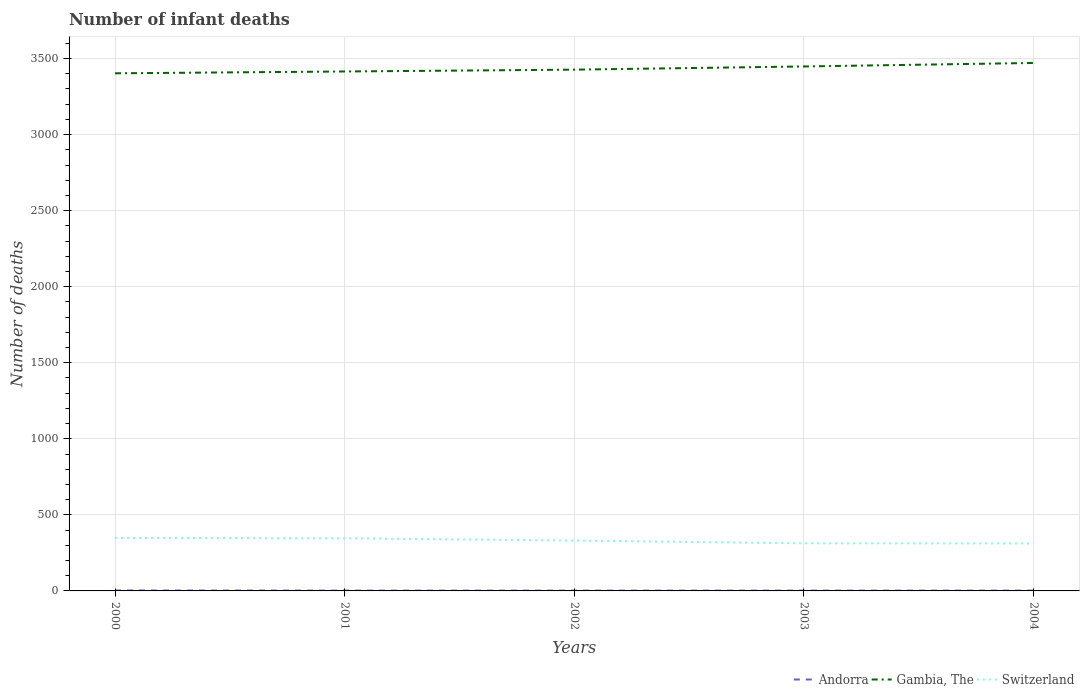Is the number of lines equal to the number of legend labels?
Keep it short and to the point. Yes. What is the total number of infant deaths in Switzerland in the graph?
Your response must be concise. 33. What is the title of the graph?
Your answer should be compact. Number of infant deaths. What is the label or title of the Y-axis?
Offer a terse response. Number of deaths. What is the Number of deaths of Andorra in 2000?
Offer a terse response. 3. What is the Number of deaths in Gambia, The in 2000?
Provide a short and direct response. 3403. What is the Number of deaths of Switzerland in 2000?
Give a very brief answer. 348. What is the Number of deaths in Gambia, The in 2001?
Provide a succinct answer. 3415. What is the Number of deaths in Switzerland in 2001?
Make the answer very short. 346. What is the Number of deaths of Gambia, The in 2002?
Ensure brevity in your answer.  3427. What is the Number of deaths of Switzerland in 2002?
Your answer should be compact. 331. What is the Number of deaths in Gambia, The in 2003?
Your answer should be very brief. 3448. What is the Number of deaths in Switzerland in 2003?
Offer a very short reply. 313. What is the Number of deaths in Andorra in 2004?
Provide a short and direct response. 2. What is the Number of deaths in Gambia, The in 2004?
Offer a very short reply. 3471. What is the Number of deaths of Switzerland in 2004?
Make the answer very short. 312. Across all years, what is the maximum Number of deaths in Gambia, The?
Offer a terse response. 3471. Across all years, what is the maximum Number of deaths in Switzerland?
Your answer should be compact. 348. Across all years, what is the minimum Number of deaths of Gambia, The?
Give a very brief answer. 3403. Across all years, what is the minimum Number of deaths in Switzerland?
Provide a short and direct response. 312. What is the total Number of deaths in Andorra in the graph?
Make the answer very short. 11. What is the total Number of deaths of Gambia, The in the graph?
Provide a short and direct response. 1.72e+04. What is the total Number of deaths of Switzerland in the graph?
Ensure brevity in your answer.  1650. What is the difference between the Number of deaths in Gambia, The in 2000 and that in 2001?
Your answer should be compact. -12. What is the difference between the Number of deaths in Switzerland in 2000 and that in 2001?
Your response must be concise. 2. What is the difference between the Number of deaths of Switzerland in 2000 and that in 2002?
Keep it short and to the point. 17. What is the difference between the Number of deaths in Gambia, The in 2000 and that in 2003?
Your answer should be very brief. -45. What is the difference between the Number of deaths of Andorra in 2000 and that in 2004?
Keep it short and to the point. 1. What is the difference between the Number of deaths in Gambia, The in 2000 and that in 2004?
Ensure brevity in your answer.  -68. What is the difference between the Number of deaths in Andorra in 2001 and that in 2003?
Offer a very short reply. 0. What is the difference between the Number of deaths of Gambia, The in 2001 and that in 2003?
Your response must be concise. -33. What is the difference between the Number of deaths of Switzerland in 2001 and that in 2003?
Provide a short and direct response. 33. What is the difference between the Number of deaths in Andorra in 2001 and that in 2004?
Your response must be concise. 0. What is the difference between the Number of deaths in Gambia, The in 2001 and that in 2004?
Ensure brevity in your answer.  -56. What is the difference between the Number of deaths in Switzerland in 2001 and that in 2004?
Offer a terse response. 34. What is the difference between the Number of deaths of Andorra in 2002 and that in 2003?
Your answer should be very brief. 0. What is the difference between the Number of deaths of Switzerland in 2002 and that in 2003?
Your answer should be compact. 18. What is the difference between the Number of deaths of Andorra in 2002 and that in 2004?
Offer a terse response. 0. What is the difference between the Number of deaths in Gambia, The in 2002 and that in 2004?
Ensure brevity in your answer.  -44. What is the difference between the Number of deaths in Switzerland in 2003 and that in 2004?
Offer a very short reply. 1. What is the difference between the Number of deaths in Andorra in 2000 and the Number of deaths in Gambia, The in 2001?
Provide a succinct answer. -3412. What is the difference between the Number of deaths of Andorra in 2000 and the Number of deaths of Switzerland in 2001?
Your answer should be very brief. -343. What is the difference between the Number of deaths of Gambia, The in 2000 and the Number of deaths of Switzerland in 2001?
Offer a terse response. 3057. What is the difference between the Number of deaths in Andorra in 2000 and the Number of deaths in Gambia, The in 2002?
Your answer should be compact. -3424. What is the difference between the Number of deaths of Andorra in 2000 and the Number of deaths of Switzerland in 2002?
Provide a short and direct response. -328. What is the difference between the Number of deaths in Gambia, The in 2000 and the Number of deaths in Switzerland in 2002?
Give a very brief answer. 3072. What is the difference between the Number of deaths of Andorra in 2000 and the Number of deaths of Gambia, The in 2003?
Keep it short and to the point. -3445. What is the difference between the Number of deaths in Andorra in 2000 and the Number of deaths in Switzerland in 2003?
Provide a short and direct response. -310. What is the difference between the Number of deaths of Gambia, The in 2000 and the Number of deaths of Switzerland in 2003?
Your answer should be compact. 3090. What is the difference between the Number of deaths in Andorra in 2000 and the Number of deaths in Gambia, The in 2004?
Your response must be concise. -3468. What is the difference between the Number of deaths of Andorra in 2000 and the Number of deaths of Switzerland in 2004?
Offer a terse response. -309. What is the difference between the Number of deaths of Gambia, The in 2000 and the Number of deaths of Switzerland in 2004?
Offer a very short reply. 3091. What is the difference between the Number of deaths of Andorra in 2001 and the Number of deaths of Gambia, The in 2002?
Your answer should be compact. -3425. What is the difference between the Number of deaths in Andorra in 2001 and the Number of deaths in Switzerland in 2002?
Your answer should be very brief. -329. What is the difference between the Number of deaths of Gambia, The in 2001 and the Number of deaths of Switzerland in 2002?
Your answer should be very brief. 3084. What is the difference between the Number of deaths in Andorra in 2001 and the Number of deaths in Gambia, The in 2003?
Provide a succinct answer. -3446. What is the difference between the Number of deaths in Andorra in 2001 and the Number of deaths in Switzerland in 2003?
Your answer should be compact. -311. What is the difference between the Number of deaths in Gambia, The in 2001 and the Number of deaths in Switzerland in 2003?
Your answer should be compact. 3102. What is the difference between the Number of deaths of Andorra in 2001 and the Number of deaths of Gambia, The in 2004?
Make the answer very short. -3469. What is the difference between the Number of deaths of Andorra in 2001 and the Number of deaths of Switzerland in 2004?
Provide a succinct answer. -310. What is the difference between the Number of deaths of Gambia, The in 2001 and the Number of deaths of Switzerland in 2004?
Your response must be concise. 3103. What is the difference between the Number of deaths of Andorra in 2002 and the Number of deaths of Gambia, The in 2003?
Provide a succinct answer. -3446. What is the difference between the Number of deaths of Andorra in 2002 and the Number of deaths of Switzerland in 2003?
Keep it short and to the point. -311. What is the difference between the Number of deaths of Gambia, The in 2002 and the Number of deaths of Switzerland in 2003?
Keep it short and to the point. 3114. What is the difference between the Number of deaths in Andorra in 2002 and the Number of deaths in Gambia, The in 2004?
Keep it short and to the point. -3469. What is the difference between the Number of deaths in Andorra in 2002 and the Number of deaths in Switzerland in 2004?
Provide a short and direct response. -310. What is the difference between the Number of deaths in Gambia, The in 2002 and the Number of deaths in Switzerland in 2004?
Your response must be concise. 3115. What is the difference between the Number of deaths of Andorra in 2003 and the Number of deaths of Gambia, The in 2004?
Your answer should be very brief. -3469. What is the difference between the Number of deaths of Andorra in 2003 and the Number of deaths of Switzerland in 2004?
Give a very brief answer. -310. What is the difference between the Number of deaths in Gambia, The in 2003 and the Number of deaths in Switzerland in 2004?
Offer a terse response. 3136. What is the average Number of deaths of Gambia, The per year?
Offer a very short reply. 3432.8. What is the average Number of deaths in Switzerland per year?
Offer a terse response. 330. In the year 2000, what is the difference between the Number of deaths in Andorra and Number of deaths in Gambia, The?
Your answer should be compact. -3400. In the year 2000, what is the difference between the Number of deaths in Andorra and Number of deaths in Switzerland?
Give a very brief answer. -345. In the year 2000, what is the difference between the Number of deaths in Gambia, The and Number of deaths in Switzerland?
Your response must be concise. 3055. In the year 2001, what is the difference between the Number of deaths in Andorra and Number of deaths in Gambia, The?
Provide a short and direct response. -3413. In the year 2001, what is the difference between the Number of deaths of Andorra and Number of deaths of Switzerland?
Offer a very short reply. -344. In the year 2001, what is the difference between the Number of deaths of Gambia, The and Number of deaths of Switzerland?
Your answer should be very brief. 3069. In the year 2002, what is the difference between the Number of deaths of Andorra and Number of deaths of Gambia, The?
Your answer should be compact. -3425. In the year 2002, what is the difference between the Number of deaths in Andorra and Number of deaths in Switzerland?
Your answer should be compact. -329. In the year 2002, what is the difference between the Number of deaths of Gambia, The and Number of deaths of Switzerland?
Provide a short and direct response. 3096. In the year 2003, what is the difference between the Number of deaths in Andorra and Number of deaths in Gambia, The?
Give a very brief answer. -3446. In the year 2003, what is the difference between the Number of deaths in Andorra and Number of deaths in Switzerland?
Your answer should be compact. -311. In the year 2003, what is the difference between the Number of deaths of Gambia, The and Number of deaths of Switzerland?
Offer a very short reply. 3135. In the year 2004, what is the difference between the Number of deaths of Andorra and Number of deaths of Gambia, The?
Give a very brief answer. -3469. In the year 2004, what is the difference between the Number of deaths of Andorra and Number of deaths of Switzerland?
Offer a terse response. -310. In the year 2004, what is the difference between the Number of deaths in Gambia, The and Number of deaths in Switzerland?
Make the answer very short. 3159. What is the ratio of the Number of deaths in Andorra in 2000 to that in 2001?
Your answer should be very brief. 1.5. What is the ratio of the Number of deaths of Switzerland in 2000 to that in 2001?
Provide a succinct answer. 1.01. What is the ratio of the Number of deaths in Gambia, The in 2000 to that in 2002?
Your answer should be very brief. 0.99. What is the ratio of the Number of deaths in Switzerland in 2000 to that in 2002?
Provide a short and direct response. 1.05. What is the ratio of the Number of deaths of Gambia, The in 2000 to that in 2003?
Provide a short and direct response. 0.99. What is the ratio of the Number of deaths in Switzerland in 2000 to that in 2003?
Your answer should be compact. 1.11. What is the ratio of the Number of deaths in Gambia, The in 2000 to that in 2004?
Provide a succinct answer. 0.98. What is the ratio of the Number of deaths in Switzerland in 2000 to that in 2004?
Your response must be concise. 1.12. What is the ratio of the Number of deaths of Andorra in 2001 to that in 2002?
Provide a succinct answer. 1. What is the ratio of the Number of deaths in Gambia, The in 2001 to that in 2002?
Keep it short and to the point. 1. What is the ratio of the Number of deaths in Switzerland in 2001 to that in 2002?
Your answer should be compact. 1.05. What is the ratio of the Number of deaths in Switzerland in 2001 to that in 2003?
Keep it short and to the point. 1.11. What is the ratio of the Number of deaths of Andorra in 2001 to that in 2004?
Your answer should be very brief. 1. What is the ratio of the Number of deaths of Gambia, The in 2001 to that in 2004?
Your answer should be very brief. 0.98. What is the ratio of the Number of deaths in Switzerland in 2001 to that in 2004?
Give a very brief answer. 1.11. What is the ratio of the Number of deaths of Switzerland in 2002 to that in 2003?
Make the answer very short. 1.06. What is the ratio of the Number of deaths in Gambia, The in 2002 to that in 2004?
Keep it short and to the point. 0.99. What is the ratio of the Number of deaths of Switzerland in 2002 to that in 2004?
Offer a terse response. 1.06. What is the ratio of the Number of deaths of Andorra in 2003 to that in 2004?
Provide a succinct answer. 1. What is the ratio of the Number of deaths of Gambia, The in 2003 to that in 2004?
Your answer should be very brief. 0.99. What is the ratio of the Number of deaths in Switzerland in 2003 to that in 2004?
Offer a very short reply. 1. What is the difference between the highest and the second highest Number of deaths of Andorra?
Offer a very short reply. 1. What is the difference between the highest and the lowest Number of deaths of Andorra?
Provide a succinct answer. 1. What is the difference between the highest and the lowest Number of deaths of Gambia, The?
Offer a very short reply. 68. What is the difference between the highest and the lowest Number of deaths in Switzerland?
Provide a succinct answer. 36. 